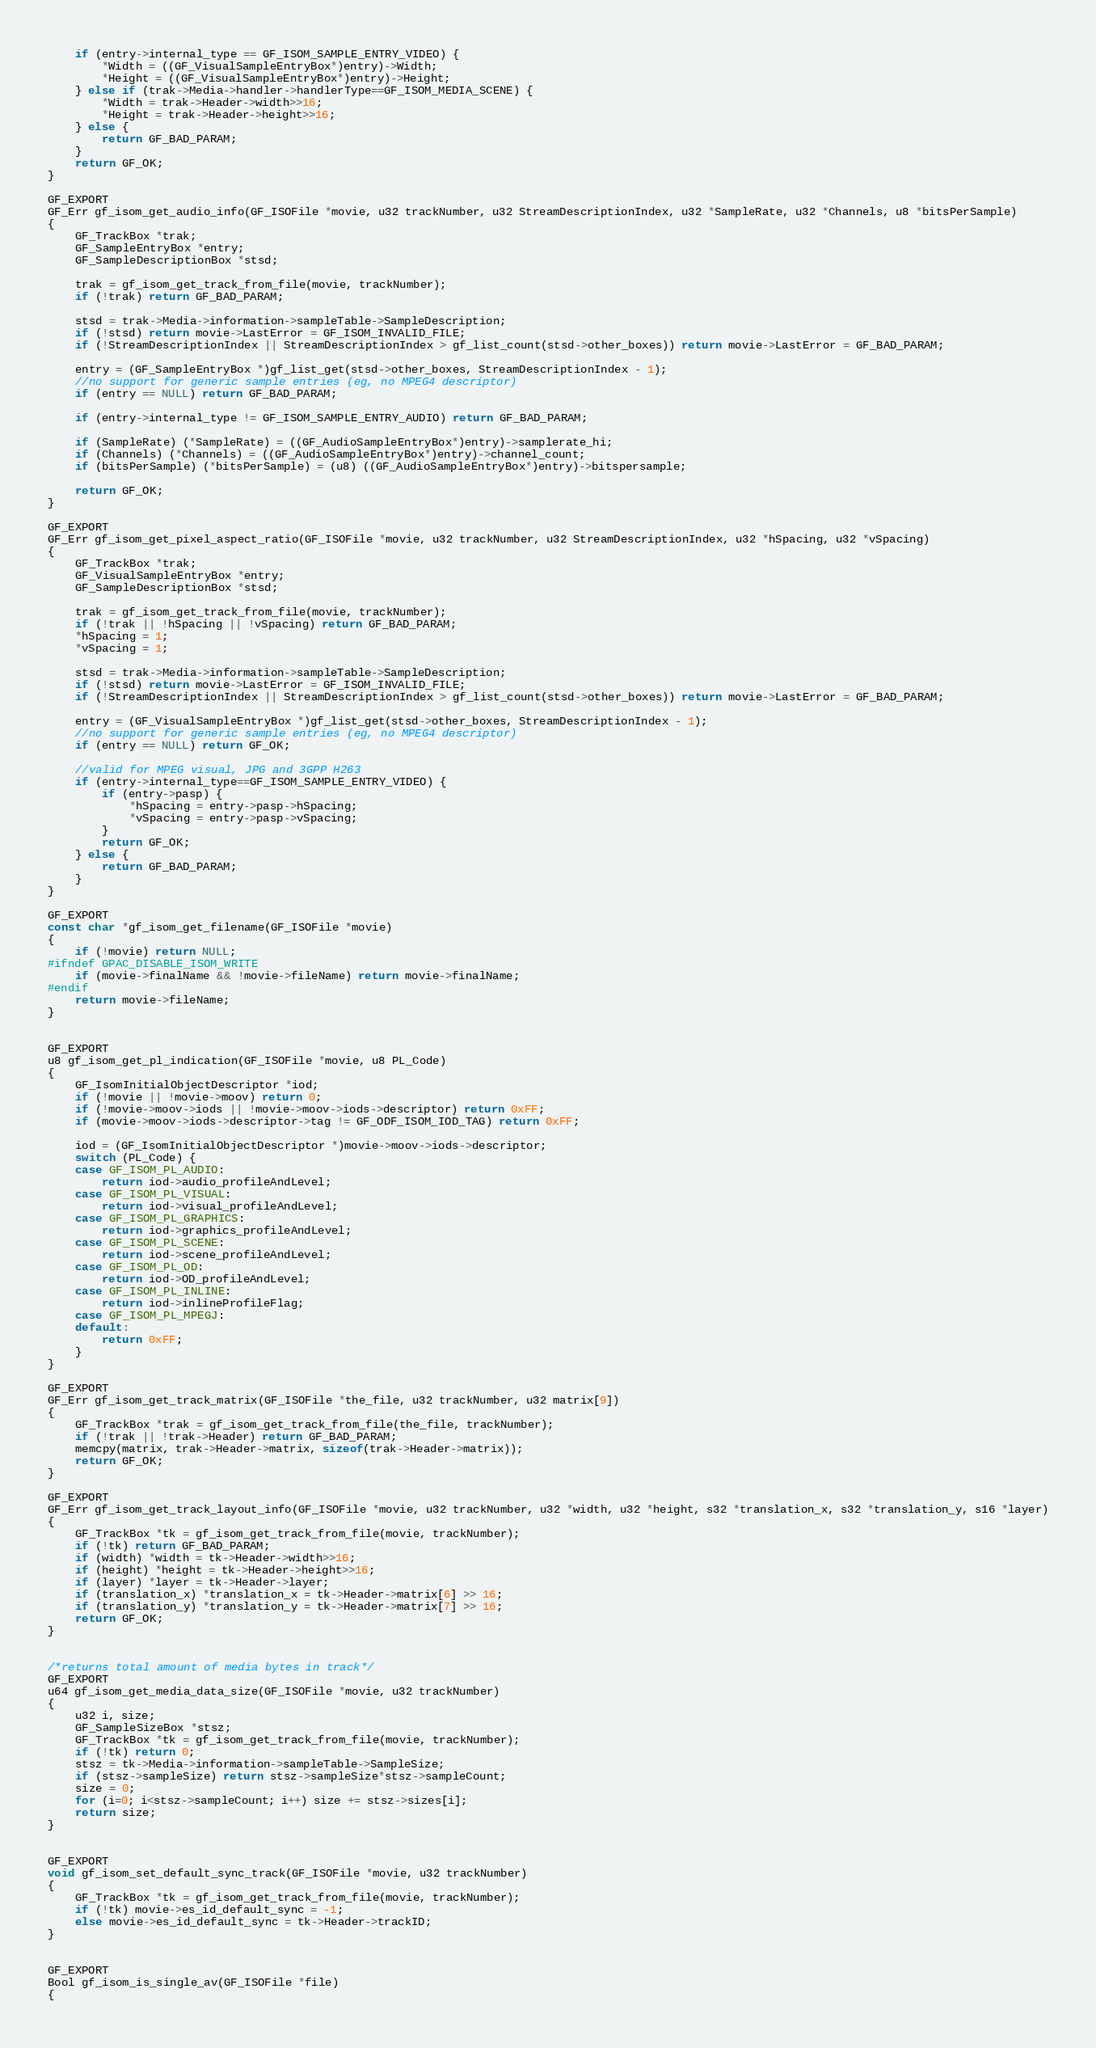Convert code to text. <code><loc_0><loc_0><loc_500><loc_500><_C_>	if (entry->internal_type == GF_ISOM_SAMPLE_ENTRY_VIDEO) {
		*Width = ((GF_VisualSampleEntryBox*)entry)->Width;
		*Height = ((GF_VisualSampleEntryBox*)entry)->Height;
	} else if (trak->Media->handler->handlerType==GF_ISOM_MEDIA_SCENE) {
		*Width = trak->Header->width>>16;
		*Height = trak->Header->height>>16;
	} else {
		return GF_BAD_PARAM;
	}
	return GF_OK;
}

GF_EXPORT
GF_Err gf_isom_get_audio_info(GF_ISOFile *movie, u32 trackNumber, u32 StreamDescriptionIndex, u32 *SampleRate, u32 *Channels, u8 *bitsPerSample)
{
	GF_TrackBox *trak;
	GF_SampleEntryBox *entry;
	GF_SampleDescriptionBox *stsd;

	trak = gf_isom_get_track_from_file(movie, trackNumber);
	if (!trak) return GF_BAD_PARAM;

	stsd = trak->Media->information->sampleTable->SampleDescription;
	if (!stsd) return movie->LastError = GF_ISOM_INVALID_FILE;
	if (!StreamDescriptionIndex || StreamDescriptionIndex > gf_list_count(stsd->other_boxes)) return movie->LastError = GF_BAD_PARAM;

	entry = (GF_SampleEntryBox *)gf_list_get(stsd->other_boxes, StreamDescriptionIndex - 1);
	//no support for generic sample entries (eg, no MPEG4 descriptor)
	if (entry == NULL) return GF_BAD_PARAM;

	if (entry->internal_type != GF_ISOM_SAMPLE_ENTRY_AUDIO) return GF_BAD_PARAM;

	if (SampleRate) (*SampleRate) = ((GF_AudioSampleEntryBox*)entry)->samplerate_hi;
	if (Channels) (*Channels) = ((GF_AudioSampleEntryBox*)entry)->channel_count;
	if (bitsPerSample) (*bitsPerSample) = (u8) ((GF_AudioSampleEntryBox*)entry)->bitspersample;

	return GF_OK;
}

GF_EXPORT
GF_Err gf_isom_get_pixel_aspect_ratio(GF_ISOFile *movie, u32 trackNumber, u32 StreamDescriptionIndex, u32 *hSpacing, u32 *vSpacing)
{
	GF_TrackBox *trak;
	GF_VisualSampleEntryBox *entry;
	GF_SampleDescriptionBox *stsd;

	trak = gf_isom_get_track_from_file(movie, trackNumber);
	if (!trak || !hSpacing || !vSpacing) return GF_BAD_PARAM;
	*hSpacing = 1;
	*vSpacing = 1;

	stsd = trak->Media->information->sampleTable->SampleDescription;
	if (!stsd) return movie->LastError = GF_ISOM_INVALID_FILE;
	if (!StreamDescriptionIndex || StreamDescriptionIndex > gf_list_count(stsd->other_boxes)) return movie->LastError = GF_BAD_PARAM;

	entry = (GF_VisualSampleEntryBox *)gf_list_get(stsd->other_boxes, StreamDescriptionIndex - 1);
	//no support for generic sample entries (eg, no MPEG4 descriptor)
	if (entry == NULL) return GF_OK;

	//valid for MPEG visual, JPG and 3GPP H263
	if (entry->internal_type==GF_ISOM_SAMPLE_ENTRY_VIDEO) {
		if (entry->pasp) {
			*hSpacing = entry->pasp->hSpacing;
			*vSpacing = entry->pasp->vSpacing;
		}
		return GF_OK;
	} else {
		return GF_BAD_PARAM;
	}
}

GF_EXPORT
const char *gf_isom_get_filename(GF_ISOFile *movie)
{
	if (!movie) return NULL;
#ifndef GPAC_DISABLE_ISOM_WRITE
	if (movie->finalName && !movie->fileName) return movie->finalName;
#endif
	return movie->fileName;
}


GF_EXPORT
u8 gf_isom_get_pl_indication(GF_ISOFile *movie, u8 PL_Code)
{
	GF_IsomInitialObjectDescriptor *iod;
	if (!movie || !movie->moov) return 0;
	if (!movie->moov->iods || !movie->moov->iods->descriptor) return 0xFF;
	if (movie->moov->iods->descriptor->tag != GF_ODF_ISOM_IOD_TAG) return 0xFF;

	iod = (GF_IsomInitialObjectDescriptor *)movie->moov->iods->descriptor;
	switch (PL_Code) {
	case GF_ISOM_PL_AUDIO:
		return iod->audio_profileAndLevel;
	case GF_ISOM_PL_VISUAL:
		return iod->visual_profileAndLevel;
	case GF_ISOM_PL_GRAPHICS:
		return iod->graphics_profileAndLevel;
	case GF_ISOM_PL_SCENE:
		return iod->scene_profileAndLevel;
	case GF_ISOM_PL_OD:
		return iod->OD_profileAndLevel;
	case GF_ISOM_PL_INLINE:
		return iod->inlineProfileFlag;
	case GF_ISOM_PL_MPEGJ:
	default:
		return 0xFF;
	}
}

GF_EXPORT
GF_Err gf_isom_get_track_matrix(GF_ISOFile *the_file, u32 trackNumber, u32 matrix[9])
{
	GF_TrackBox *trak = gf_isom_get_track_from_file(the_file, trackNumber);
	if (!trak || !trak->Header) return GF_BAD_PARAM;
	memcpy(matrix, trak->Header->matrix, sizeof(trak->Header->matrix));
	return GF_OK;
}

GF_EXPORT
GF_Err gf_isom_get_track_layout_info(GF_ISOFile *movie, u32 trackNumber, u32 *width, u32 *height, s32 *translation_x, s32 *translation_y, s16 *layer)
{
	GF_TrackBox *tk = gf_isom_get_track_from_file(movie, trackNumber);
	if (!tk) return GF_BAD_PARAM;
	if (width) *width = tk->Header->width>>16;
	if (height) *height = tk->Header->height>>16;
	if (layer) *layer = tk->Header->layer;
	if (translation_x) *translation_x = tk->Header->matrix[6] >> 16;
	if (translation_y) *translation_y = tk->Header->matrix[7] >> 16;
	return GF_OK;
}


/*returns total amount of media bytes in track*/
GF_EXPORT
u64 gf_isom_get_media_data_size(GF_ISOFile *movie, u32 trackNumber)
{
	u32 i, size;
	GF_SampleSizeBox *stsz;
	GF_TrackBox *tk = gf_isom_get_track_from_file(movie, trackNumber);
	if (!tk) return 0;
	stsz = tk->Media->information->sampleTable->SampleSize;
	if (stsz->sampleSize) return stsz->sampleSize*stsz->sampleCount;
	size = 0;
	for (i=0; i<stsz->sampleCount; i++) size += stsz->sizes[i];
	return size;
}


GF_EXPORT
void gf_isom_set_default_sync_track(GF_ISOFile *movie, u32 trackNumber)
{
	GF_TrackBox *tk = gf_isom_get_track_from_file(movie, trackNumber);
	if (!tk) movie->es_id_default_sync = -1;
	else movie->es_id_default_sync = tk->Header->trackID;
}


GF_EXPORT
Bool gf_isom_is_single_av(GF_ISOFile *file)
{</code> 